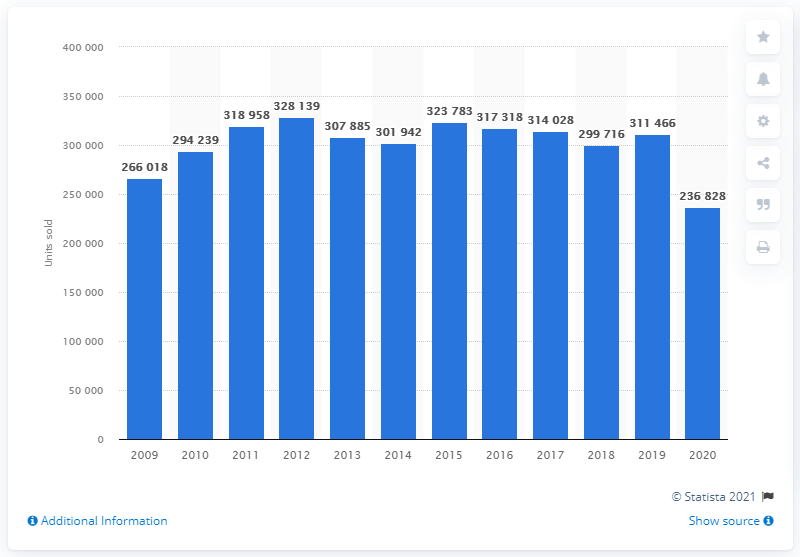Outline some significant characteristics in this image. During the period of 2009 to 2012, the peak number of passenger car sales reached 328,139 units. In 2020, a total of 236,828 passenger cars were sold in Switzerland. 